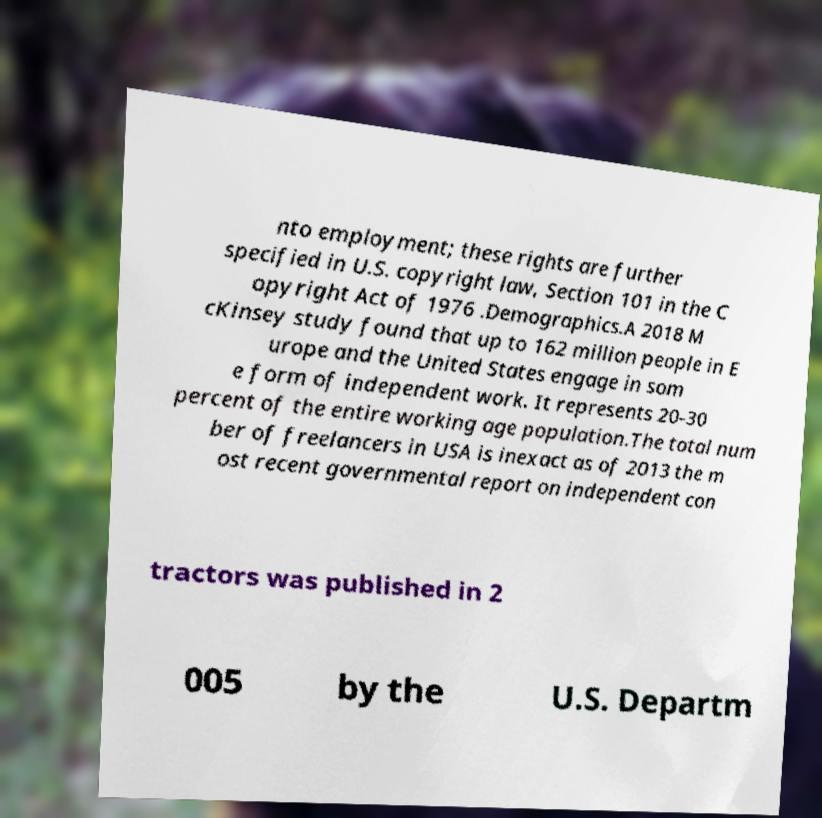Could you extract and type out the text from this image? nto employment; these rights are further specified in U.S. copyright law, Section 101 in the C opyright Act of 1976 .Demographics.A 2018 M cKinsey study found that up to 162 million people in E urope and the United States engage in som e form of independent work. It represents 20-30 percent of the entire working age population.The total num ber of freelancers in USA is inexact as of 2013 the m ost recent governmental report on independent con tractors was published in 2 005 by the U.S. Departm 